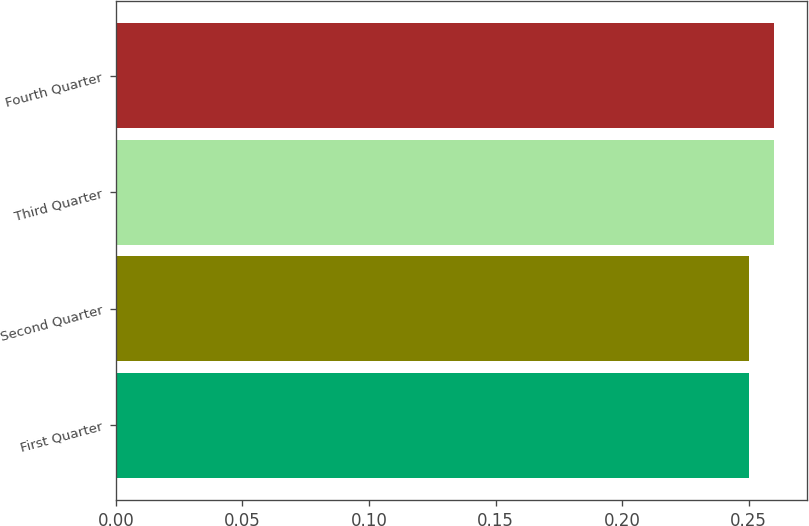Convert chart to OTSL. <chart><loc_0><loc_0><loc_500><loc_500><bar_chart><fcel>First Quarter<fcel>Second Quarter<fcel>Third Quarter<fcel>Fourth Quarter<nl><fcel>0.25<fcel>0.25<fcel>0.26<fcel>0.26<nl></chart> 